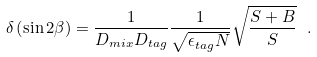Convert formula to latex. <formula><loc_0><loc_0><loc_500><loc_500>\delta \left ( \sin 2 \beta \right ) = \frac { 1 } { D _ { m i x } D _ { t a g } } \frac { 1 } { \sqrt { \epsilon _ { t a g } N } } \sqrt { \frac { S + B } { S } } \ .</formula> 